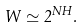<formula> <loc_0><loc_0><loc_500><loc_500>W \simeq 2 ^ { N H } .</formula> 